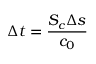<formula> <loc_0><loc_0><loc_500><loc_500>\Delta t = \frac { S _ { c } \Delta s } { c _ { 0 } }</formula> 